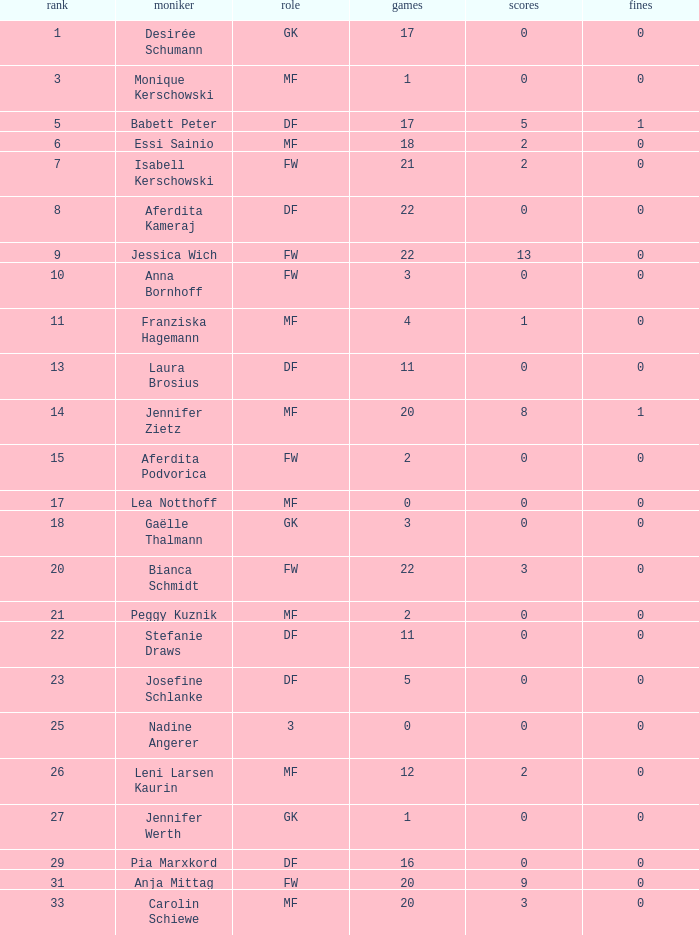What is the average goals for Essi Sainio? 2.0. 